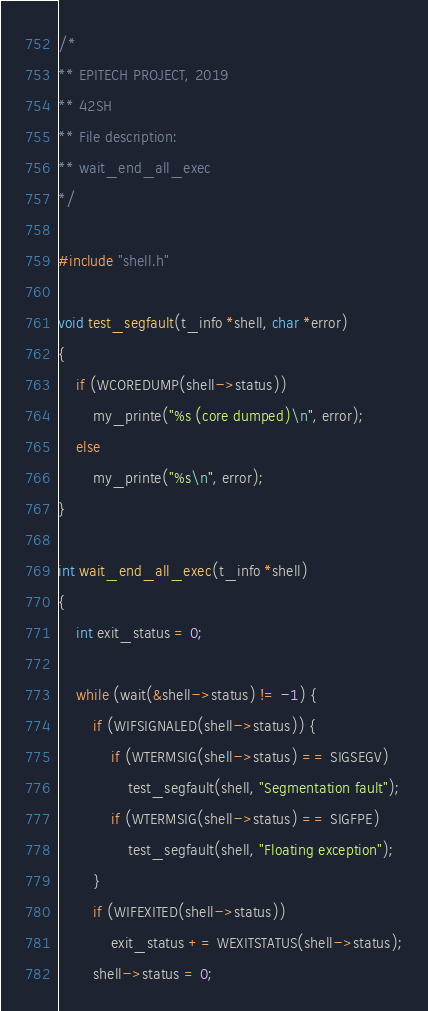Convert code to text. <code><loc_0><loc_0><loc_500><loc_500><_C_>/*
** EPITECH PROJECT, 2019
** 42SH
** File description:
** wait_end_all_exec
*/

#include "shell.h"

void test_segfault(t_info *shell, char *error)
{
    if (WCOREDUMP(shell->status))
        my_printe("%s (core dumped)\n", error);
    else
        my_printe("%s\n", error);
}

int wait_end_all_exec(t_info *shell)
{
    int exit_status = 0;

    while (wait(&shell->status) != -1) {
        if (WIFSIGNALED(shell->status)) {
            if (WTERMSIG(shell->status) == SIGSEGV)
                test_segfault(shell, "Segmentation fault");
            if (WTERMSIG(shell->status) == SIGFPE)
                test_segfault(shell, "Floating exception");
        }
        if (WIFEXITED(shell->status))
            exit_status += WEXITSTATUS(shell->status);
        shell->status = 0;</code> 